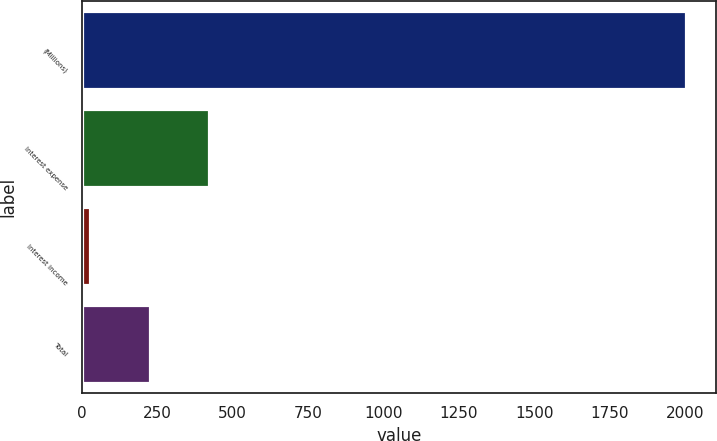Convert chart. <chart><loc_0><loc_0><loc_500><loc_500><bar_chart><fcel>(Millions)<fcel>Interest expense<fcel>Interest income<fcel>Total<nl><fcel>2003<fcel>423<fcel>28<fcel>225.5<nl></chart> 